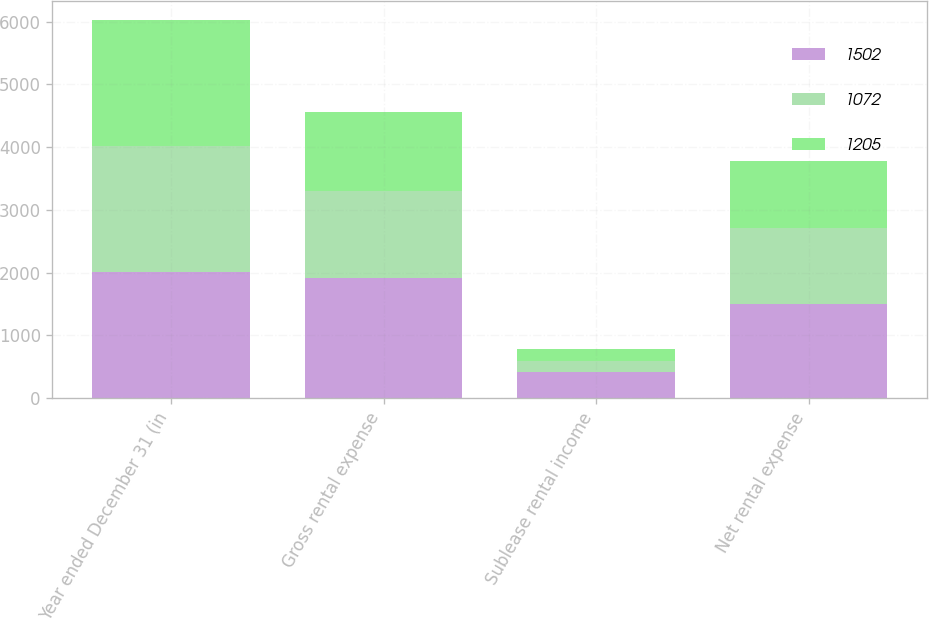<chart> <loc_0><loc_0><loc_500><loc_500><stacked_bar_chart><ecel><fcel>Year ended December 31 (in<fcel>Gross rental expense<fcel>Sublease rental income<fcel>Net rental expense<nl><fcel>1502<fcel>2008<fcel>1917<fcel>415<fcel>1502<nl><fcel>1072<fcel>2007<fcel>1380<fcel>175<fcel>1205<nl><fcel>1205<fcel>2006<fcel>1266<fcel>194<fcel>1072<nl></chart> 